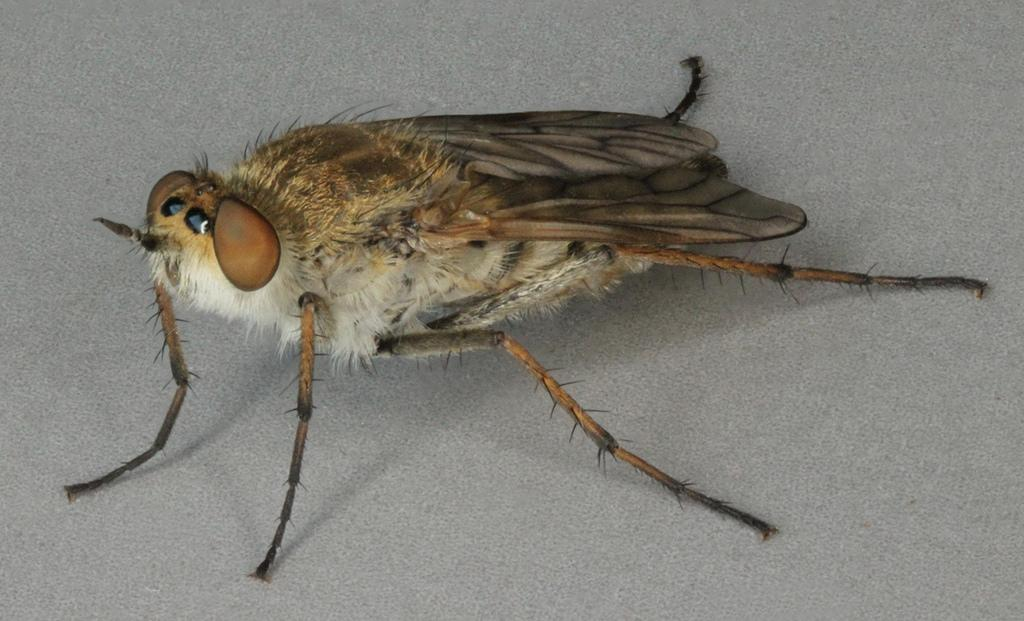What type of creature can be seen on the surface in the image? There is an insect on the surface in the image. What color is the tail of the insect in the image? There is no tail present on the insect in the image, as insects do not have tails. 